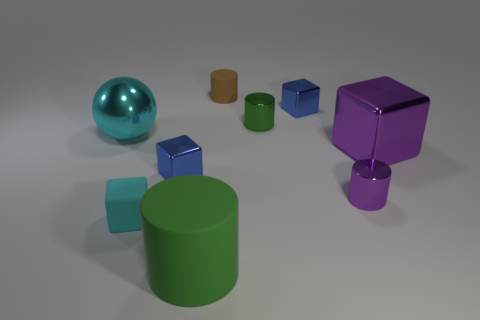Can you tell if the lighting in this scene comes from a natural or artificial source? The lighting in the scene appears to be artificial as it casts soft shadows uniformly, suggesting a controlled environment typical of indoor lighting setups, possibly achieved through computer-generated imagery. 